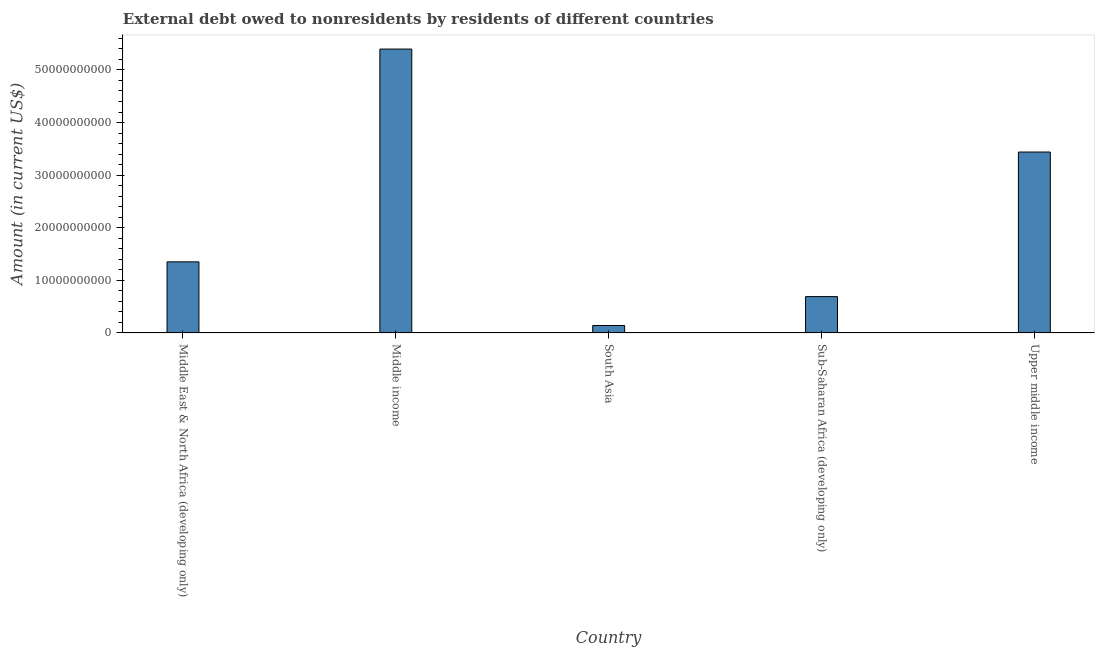What is the title of the graph?
Keep it short and to the point. External debt owed to nonresidents by residents of different countries. What is the debt in Middle income?
Your answer should be compact. 5.40e+1. Across all countries, what is the maximum debt?
Your answer should be compact. 5.40e+1. Across all countries, what is the minimum debt?
Offer a terse response. 1.42e+09. What is the sum of the debt?
Provide a succinct answer. 1.10e+11. What is the difference between the debt in South Asia and Upper middle income?
Your response must be concise. -3.30e+1. What is the average debt per country?
Offer a very short reply. 2.20e+1. What is the median debt?
Give a very brief answer. 1.35e+1. What is the ratio of the debt in Middle income to that in Sub-Saharan Africa (developing only)?
Make the answer very short. 7.81. What is the difference between the highest and the second highest debt?
Your response must be concise. 1.96e+1. What is the difference between the highest and the lowest debt?
Ensure brevity in your answer.  5.26e+1. In how many countries, is the debt greater than the average debt taken over all countries?
Offer a terse response. 2. Are all the bars in the graph horizontal?
Make the answer very short. No. How many countries are there in the graph?
Your answer should be very brief. 5. What is the Amount (in current US$) of Middle East & North Africa (developing only)?
Make the answer very short. 1.35e+1. What is the Amount (in current US$) in Middle income?
Ensure brevity in your answer.  5.40e+1. What is the Amount (in current US$) of South Asia?
Your response must be concise. 1.42e+09. What is the Amount (in current US$) of Sub-Saharan Africa (developing only)?
Give a very brief answer. 6.91e+09. What is the Amount (in current US$) in Upper middle income?
Ensure brevity in your answer.  3.44e+1. What is the difference between the Amount (in current US$) in Middle East & North Africa (developing only) and Middle income?
Provide a short and direct response. -4.05e+1. What is the difference between the Amount (in current US$) in Middle East & North Africa (developing only) and South Asia?
Give a very brief answer. 1.21e+1. What is the difference between the Amount (in current US$) in Middle East & North Africa (developing only) and Sub-Saharan Africa (developing only)?
Ensure brevity in your answer.  6.61e+09. What is the difference between the Amount (in current US$) in Middle East & North Africa (developing only) and Upper middle income?
Ensure brevity in your answer.  -2.09e+1. What is the difference between the Amount (in current US$) in Middle income and South Asia?
Provide a succinct answer. 5.26e+1. What is the difference between the Amount (in current US$) in Middle income and Sub-Saharan Africa (developing only)?
Ensure brevity in your answer.  4.71e+1. What is the difference between the Amount (in current US$) in Middle income and Upper middle income?
Offer a very short reply. 1.96e+1. What is the difference between the Amount (in current US$) in South Asia and Sub-Saharan Africa (developing only)?
Offer a terse response. -5.49e+09. What is the difference between the Amount (in current US$) in South Asia and Upper middle income?
Your answer should be compact. -3.30e+1. What is the difference between the Amount (in current US$) in Sub-Saharan Africa (developing only) and Upper middle income?
Ensure brevity in your answer.  -2.75e+1. What is the ratio of the Amount (in current US$) in Middle East & North Africa (developing only) to that in Middle income?
Make the answer very short. 0.25. What is the ratio of the Amount (in current US$) in Middle East & North Africa (developing only) to that in South Asia?
Your answer should be compact. 9.54. What is the ratio of the Amount (in current US$) in Middle East & North Africa (developing only) to that in Sub-Saharan Africa (developing only)?
Your response must be concise. 1.96. What is the ratio of the Amount (in current US$) in Middle East & North Africa (developing only) to that in Upper middle income?
Your response must be concise. 0.39. What is the ratio of the Amount (in current US$) in Middle income to that in South Asia?
Your answer should be compact. 38.09. What is the ratio of the Amount (in current US$) in Middle income to that in Sub-Saharan Africa (developing only)?
Provide a short and direct response. 7.81. What is the ratio of the Amount (in current US$) in Middle income to that in Upper middle income?
Offer a very short reply. 1.57. What is the ratio of the Amount (in current US$) in South Asia to that in Sub-Saharan Africa (developing only)?
Keep it short and to the point. 0.2. What is the ratio of the Amount (in current US$) in South Asia to that in Upper middle income?
Provide a short and direct response. 0.04. What is the ratio of the Amount (in current US$) in Sub-Saharan Africa (developing only) to that in Upper middle income?
Give a very brief answer. 0.2. 